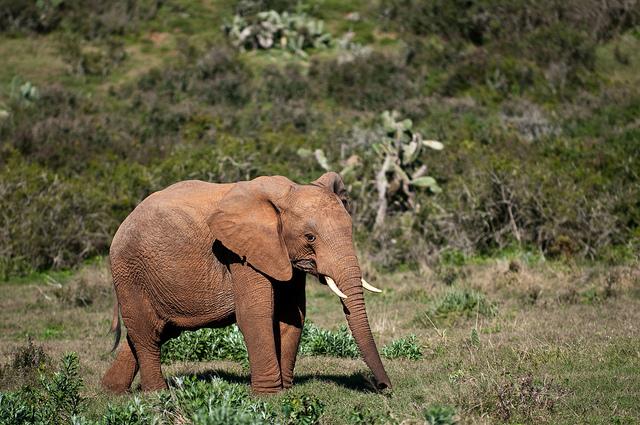What are the white things on the elephant?
Short answer required. Tusks. How many elephants are there?
Short answer required. 1. What color is this elephant?
Concise answer only. Brown. Is the elephant stampeding?
Keep it brief. No. 